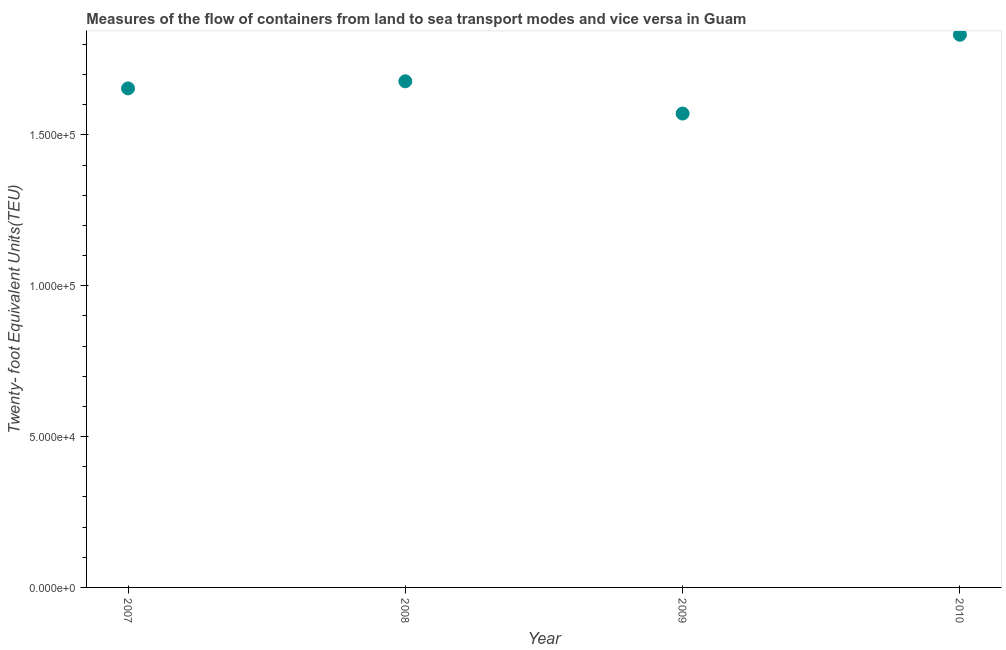What is the container port traffic in 2008?
Offer a very short reply. 1.68e+05. Across all years, what is the maximum container port traffic?
Ensure brevity in your answer.  1.83e+05. Across all years, what is the minimum container port traffic?
Make the answer very short. 1.57e+05. In which year was the container port traffic maximum?
Your answer should be compact. 2010. What is the sum of the container port traffic?
Make the answer very short. 6.74e+05. What is the difference between the container port traffic in 2007 and 2010?
Provide a short and direct response. -1.78e+04. What is the average container port traffic per year?
Ensure brevity in your answer.  1.68e+05. What is the median container port traffic?
Provide a succinct answer. 1.67e+05. Do a majority of the years between 2007 and 2010 (inclusive) have container port traffic greater than 160000 TEU?
Ensure brevity in your answer.  Yes. What is the ratio of the container port traffic in 2007 to that in 2008?
Give a very brief answer. 0.99. Is the difference between the container port traffic in 2009 and 2010 greater than the difference between any two years?
Keep it short and to the point. Yes. What is the difference between the highest and the second highest container port traffic?
Keep it short and to the point. 1.54e+04. What is the difference between the highest and the lowest container port traffic?
Your response must be concise. 2.61e+04. In how many years, is the container port traffic greater than the average container port traffic taken over all years?
Keep it short and to the point. 1. Does the graph contain grids?
Your answer should be very brief. No. What is the title of the graph?
Your response must be concise. Measures of the flow of containers from land to sea transport modes and vice versa in Guam. What is the label or title of the X-axis?
Your response must be concise. Year. What is the label or title of the Y-axis?
Provide a short and direct response. Twenty- foot Equivalent Units(TEU). What is the Twenty- foot Equivalent Units(TEU) in 2007?
Offer a very short reply. 1.65e+05. What is the Twenty- foot Equivalent Units(TEU) in 2008?
Your answer should be very brief. 1.68e+05. What is the Twenty- foot Equivalent Units(TEU) in 2009?
Ensure brevity in your answer.  1.57e+05. What is the Twenty- foot Equivalent Units(TEU) in 2010?
Offer a very short reply. 1.83e+05. What is the difference between the Twenty- foot Equivalent Units(TEU) in 2007 and 2008?
Give a very brief answer. -2357. What is the difference between the Twenty- foot Equivalent Units(TEU) in 2007 and 2009?
Your response must be concise. 8331. What is the difference between the Twenty- foot Equivalent Units(TEU) in 2007 and 2010?
Provide a short and direct response. -1.78e+04. What is the difference between the Twenty- foot Equivalent Units(TEU) in 2008 and 2009?
Give a very brief answer. 1.07e+04. What is the difference between the Twenty- foot Equivalent Units(TEU) in 2008 and 2010?
Give a very brief answer. -1.54e+04. What is the difference between the Twenty- foot Equivalent Units(TEU) in 2009 and 2010?
Keep it short and to the point. -2.61e+04. What is the ratio of the Twenty- foot Equivalent Units(TEU) in 2007 to that in 2009?
Give a very brief answer. 1.05. What is the ratio of the Twenty- foot Equivalent Units(TEU) in 2007 to that in 2010?
Your answer should be compact. 0.9. What is the ratio of the Twenty- foot Equivalent Units(TEU) in 2008 to that in 2009?
Offer a terse response. 1.07. What is the ratio of the Twenty- foot Equivalent Units(TEU) in 2008 to that in 2010?
Offer a terse response. 0.92. What is the ratio of the Twenty- foot Equivalent Units(TEU) in 2009 to that in 2010?
Provide a short and direct response. 0.86. 